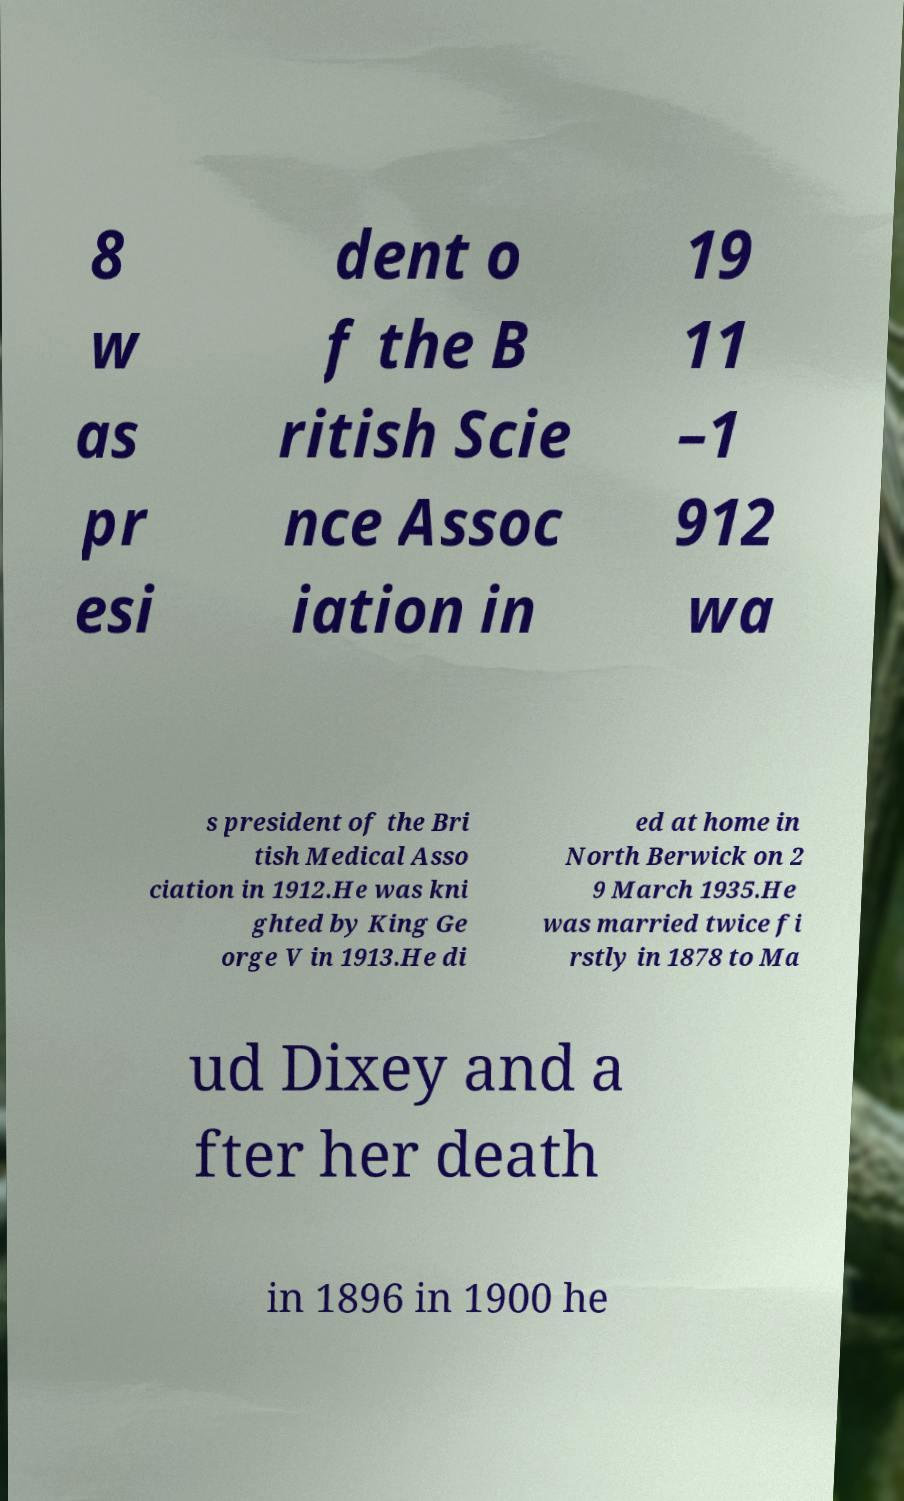Please read and relay the text visible in this image. What does it say? 8 w as pr esi dent o f the B ritish Scie nce Assoc iation in 19 11 –1 912 wa s president of the Bri tish Medical Asso ciation in 1912.He was kni ghted by King Ge orge V in 1913.He di ed at home in North Berwick on 2 9 March 1935.He was married twice fi rstly in 1878 to Ma ud Dixey and a fter her death in 1896 in 1900 he 